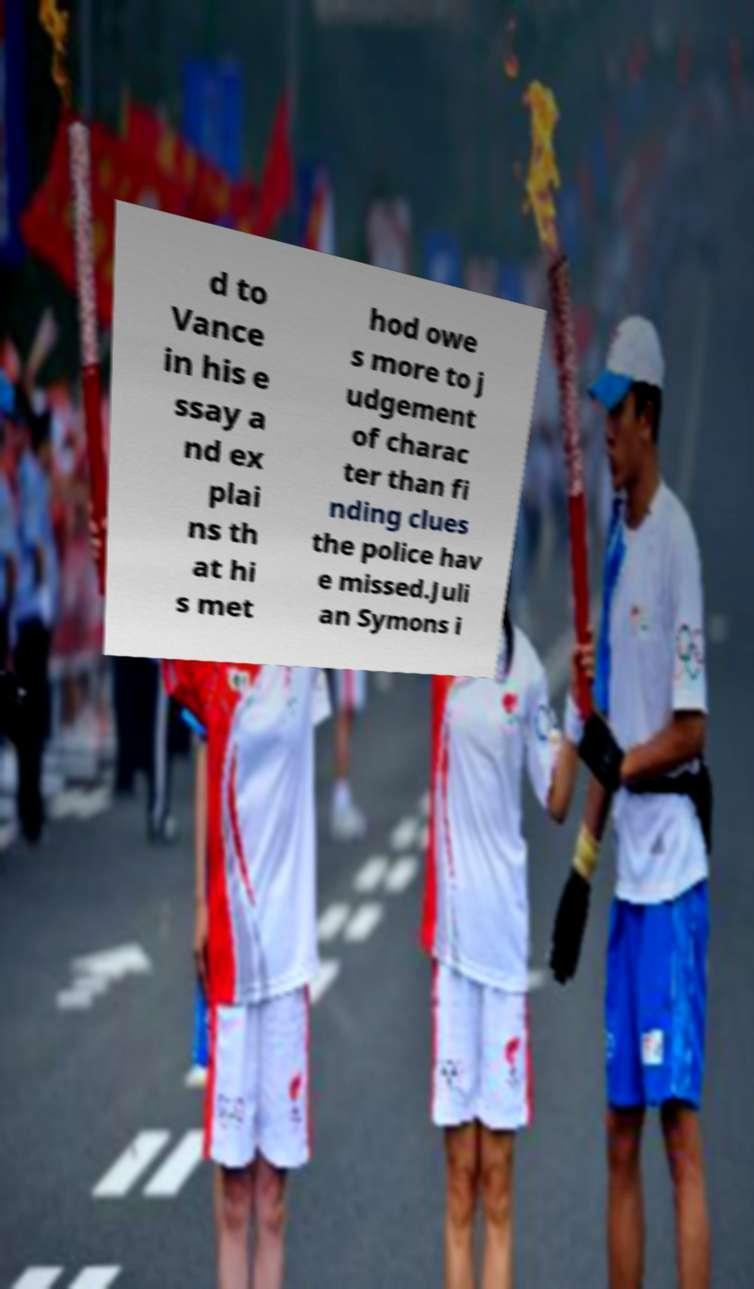Could you assist in decoding the text presented in this image and type it out clearly? d to Vance in his e ssay a nd ex plai ns th at hi s met hod owe s more to j udgement of charac ter than fi nding clues the police hav e missed.Juli an Symons i 